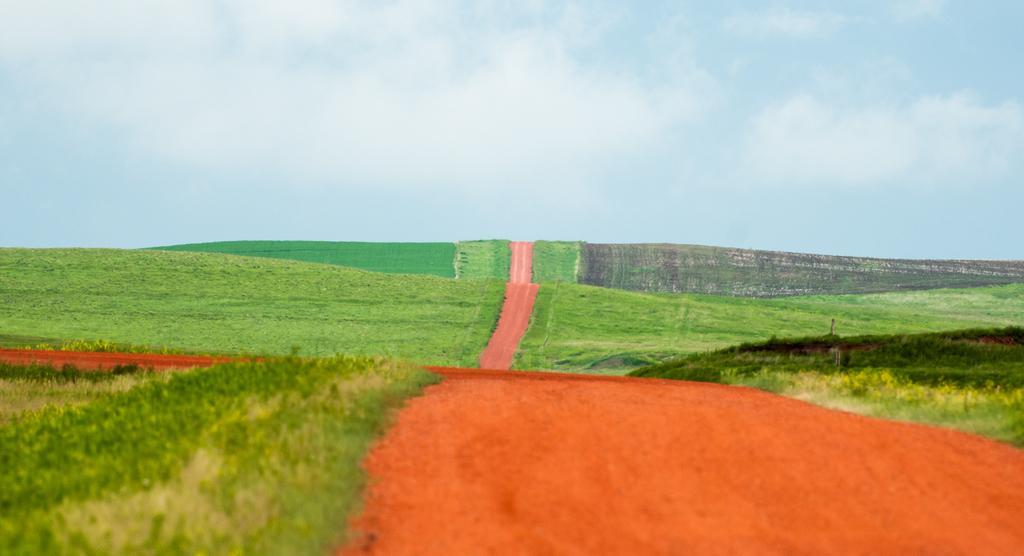Please provide a concise description of this image. In this image I can see an open grass ground and in the centre I can see a path. In the background I can see clouds and the sky. 